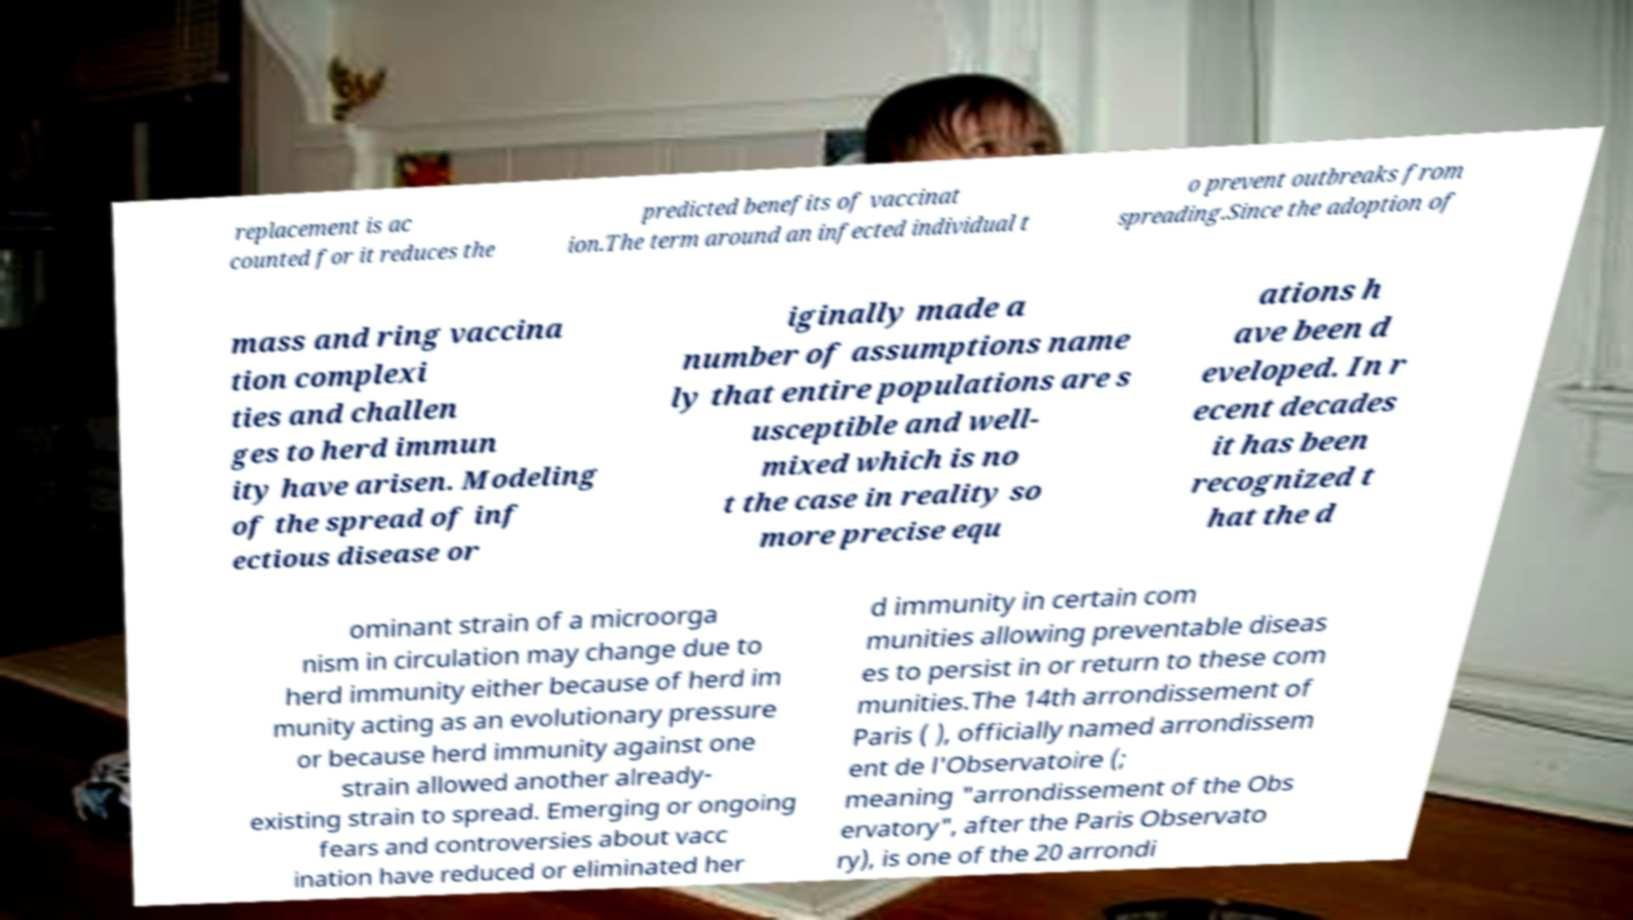There's text embedded in this image that I need extracted. Can you transcribe it verbatim? replacement is ac counted for it reduces the predicted benefits of vaccinat ion.The term around an infected individual t o prevent outbreaks from spreading.Since the adoption of mass and ring vaccina tion complexi ties and challen ges to herd immun ity have arisen. Modeling of the spread of inf ectious disease or iginally made a number of assumptions name ly that entire populations are s usceptible and well- mixed which is no t the case in reality so more precise equ ations h ave been d eveloped. In r ecent decades it has been recognized t hat the d ominant strain of a microorga nism in circulation may change due to herd immunity either because of herd im munity acting as an evolutionary pressure or because herd immunity against one strain allowed another already- existing strain to spread. Emerging or ongoing fears and controversies about vacc ination have reduced or eliminated her d immunity in certain com munities allowing preventable diseas es to persist in or return to these com munities.The 14th arrondissement of Paris ( ), officially named arrondissem ent de l'Observatoire (; meaning "arrondissement of the Obs ervatory", after the Paris Observato ry), is one of the 20 arrondi 